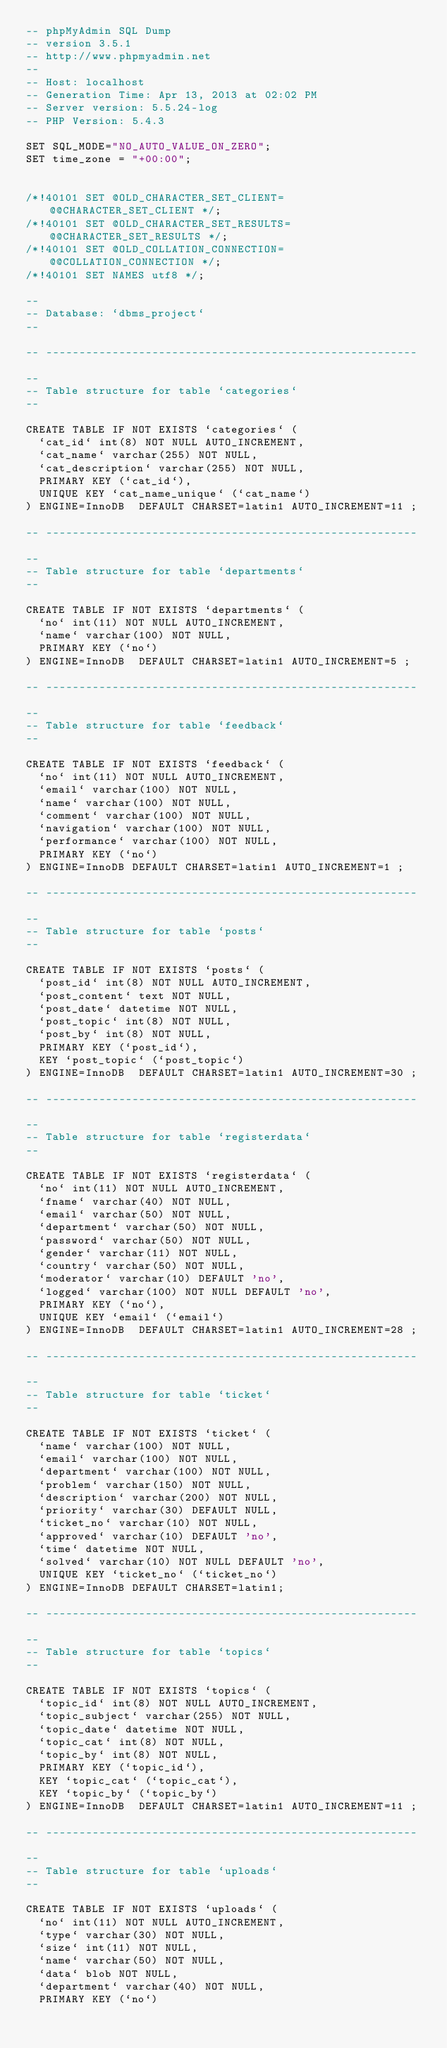<code> <loc_0><loc_0><loc_500><loc_500><_SQL_>-- phpMyAdmin SQL Dump
-- version 3.5.1
-- http://www.phpmyadmin.net
--
-- Host: localhost
-- Generation Time: Apr 13, 2013 at 02:02 PM
-- Server version: 5.5.24-log
-- PHP Version: 5.4.3

SET SQL_MODE="NO_AUTO_VALUE_ON_ZERO";
SET time_zone = "+00:00";


/*!40101 SET @OLD_CHARACTER_SET_CLIENT=@@CHARACTER_SET_CLIENT */;
/*!40101 SET @OLD_CHARACTER_SET_RESULTS=@@CHARACTER_SET_RESULTS */;
/*!40101 SET @OLD_COLLATION_CONNECTION=@@COLLATION_CONNECTION */;
/*!40101 SET NAMES utf8 */;

--
-- Database: `dbms_project`
--

-- --------------------------------------------------------

--
-- Table structure for table `categories`
--

CREATE TABLE IF NOT EXISTS `categories` (
  `cat_id` int(8) NOT NULL AUTO_INCREMENT,
  `cat_name` varchar(255) NOT NULL,
  `cat_description` varchar(255) NOT NULL,
  PRIMARY KEY (`cat_id`),
  UNIQUE KEY `cat_name_unique` (`cat_name`)
) ENGINE=InnoDB  DEFAULT CHARSET=latin1 AUTO_INCREMENT=11 ;

-- --------------------------------------------------------

--
-- Table structure for table `departments`
--

CREATE TABLE IF NOT EXISTS `departments` (
  `no` int(11) NOT NULL AUTO_INCREMENT,
  `name` varchar(100) NOT NULL,
  PRIMARY KEY (`no`)
) ENGINE=InnoDB  DEFAULT CHARSET=latin1 AUTO_INCREMENT=5 ;

-- --------------------------------------------------------

--
-- Table structure for table `feedback`
--

CREATE TABLE IF NOT EXISTS `feedback` (
  `no` int(11) NOT NULL AUTO_INCREMENT,
  `email` varchar(100) NOT NULL,
  `name` varchar(100) NOT NULL,
  `comment` varchar(100) NOT NULL,
  `navigation` varchar(100) NOT NULL,
  `performance` varchar(100) NOT NULL,
  PRIMARY KEY (`no`)
) ENGINE=InnoDB DEFAULT CHARSET=latin1 AUTO_INCREMENT=1 ;

-- --------------------------------------------------------

--
-- Table structure for table `posts`
--

CREATE TABLE IF NOT EXISTS `posts` (
  `post_id` int(8) NOT NULL AUTO_INCREMENT,
  `post_content` text NOT NULL,
  `post_date` datetime NOT NULL,
  `post_topic` int(8) NOT NULL,
  `post_by` int(8) NOT NULL,
  PRIMARY KEY (`post_id`),
  KEY `post_topic` (`post_topic`)
) ENGINE=InnoDB  DEFAULT CHARSET=latin1 AUTO_INCREMENT=30 ;

-- --------------------------------------------------------

--
-- Table structure for table `registerdata`
--

CREATE TABLE IF NOT EXISTS `registerdata` (
  `no` int(11) NOT NULL AUTO_INCREMENT,
  `fname` varchar(40) NOT NULL,
  `email` varchar(50) NOT NULL,
  `department` varchar(50) NOT NULL,
  `password` varchar(50) NOT NULL,
  `gender` varchar(11) NOT NULL,
  `country` varchar(50) NOT NULL,
  `moderator` varchar(10) DEFAULT 'no',
  `logged` varchar(100) NOT NULL DEFAULT 'no',
  PRIMARY KEY (`no`),
  UNIQUE KEY `email` (`email`)
) ENGINE=InnoDB  DEFAULT CHARSET=latin1 AUTO_INCREMENT=28 ;

-- --------------------------------------------------------

--
-- Table structure for table `ticket`
--

CREATE TABLE IF NOT EXISTS `ticket` (
  `name` varchar(100) NOT NULL,
  `email` varchar(100) NOT NULL,
  `department` varchar(100) NOT NULL,
  `problem` varchar(150) NOT NULL,
  `description` varchar(200) NOT NULL,
  `priority` varchar(30) DEFAULT NULL,
  `ticket_no` varchar(10) NOT NULL,
  `approved` varchar(10) DEFAULT 'no',
  `time` datetime NOT NULL,
  `solved` varchar(10) NOT NULL DEFAULT 'no',
  UNIQUE KEY `ticket_no` (`ticket_no`)
) ENGINE=InnoDB DEFAULT CHARSET=latin1;

-- --------------------------------------------------------

--
-- Table structure for table `topics`
--

CREATE TABLE IF NOT EXISTS `topics` (
  `topic_id` int(8) NOT NULL AUTO_INCREMENT,
  `topic_subject` varchar(255) NOT NULL,
  `topic_date` datetime NOT NULL,
  `topic_cat` int(8) NOT NULL,
  `topic_by` int(8) NOT NULL,
  PRIMARY KEY (`topic_id`),
  KEY `topic_cat` (`topic_cat`),
  KEY `topic_by` (`topic_by`)
) ENGINE=InnoDB  DEFAULT CHARSET=latin1 AUTO_INCREMENT=11 ;

-- --------------------------------------------------------

--
-- Table structure for table `uploads`
--

CREATE TABLE IF NOT EXISTS `uploads` (
  `no` int(11) NOT NULL AUTO_INCREMENT,
  `type` varchar(30) NOT NULL,
  `size` int(11) NOT NULL,
  `name` varchar(50) NOT NULL,
  `data` blob NOT NULL,
  `department` varchar(40) NOT NULL,
  PRIMARY KEY (`no`)</code> 